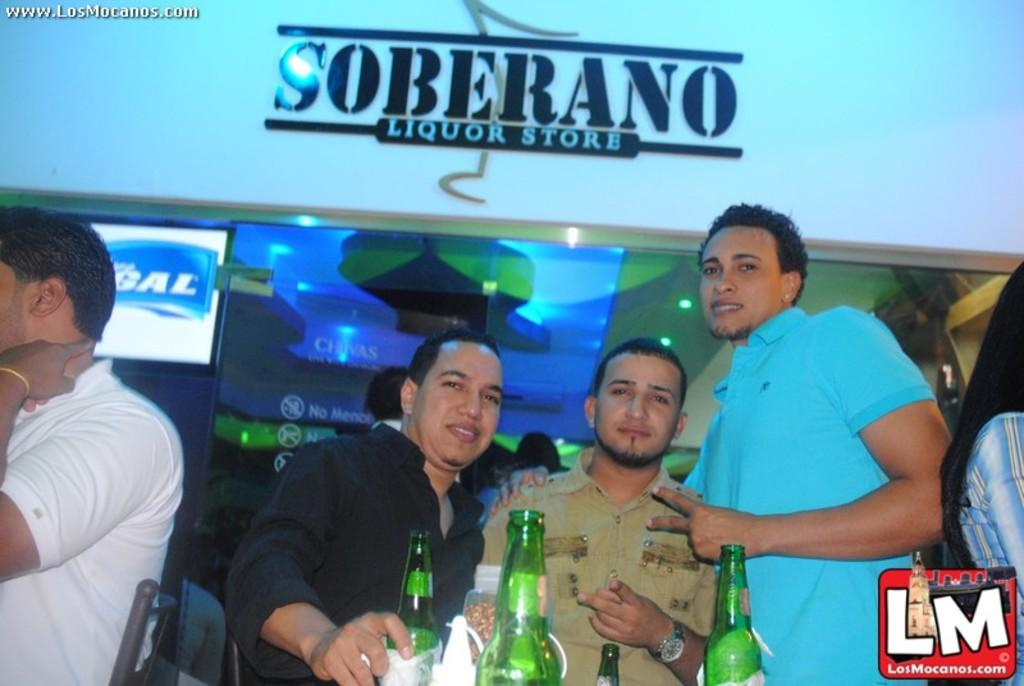<image>
Present a compact description of the photo's key features. Three man stand in front of a Soberana Liquour Store 